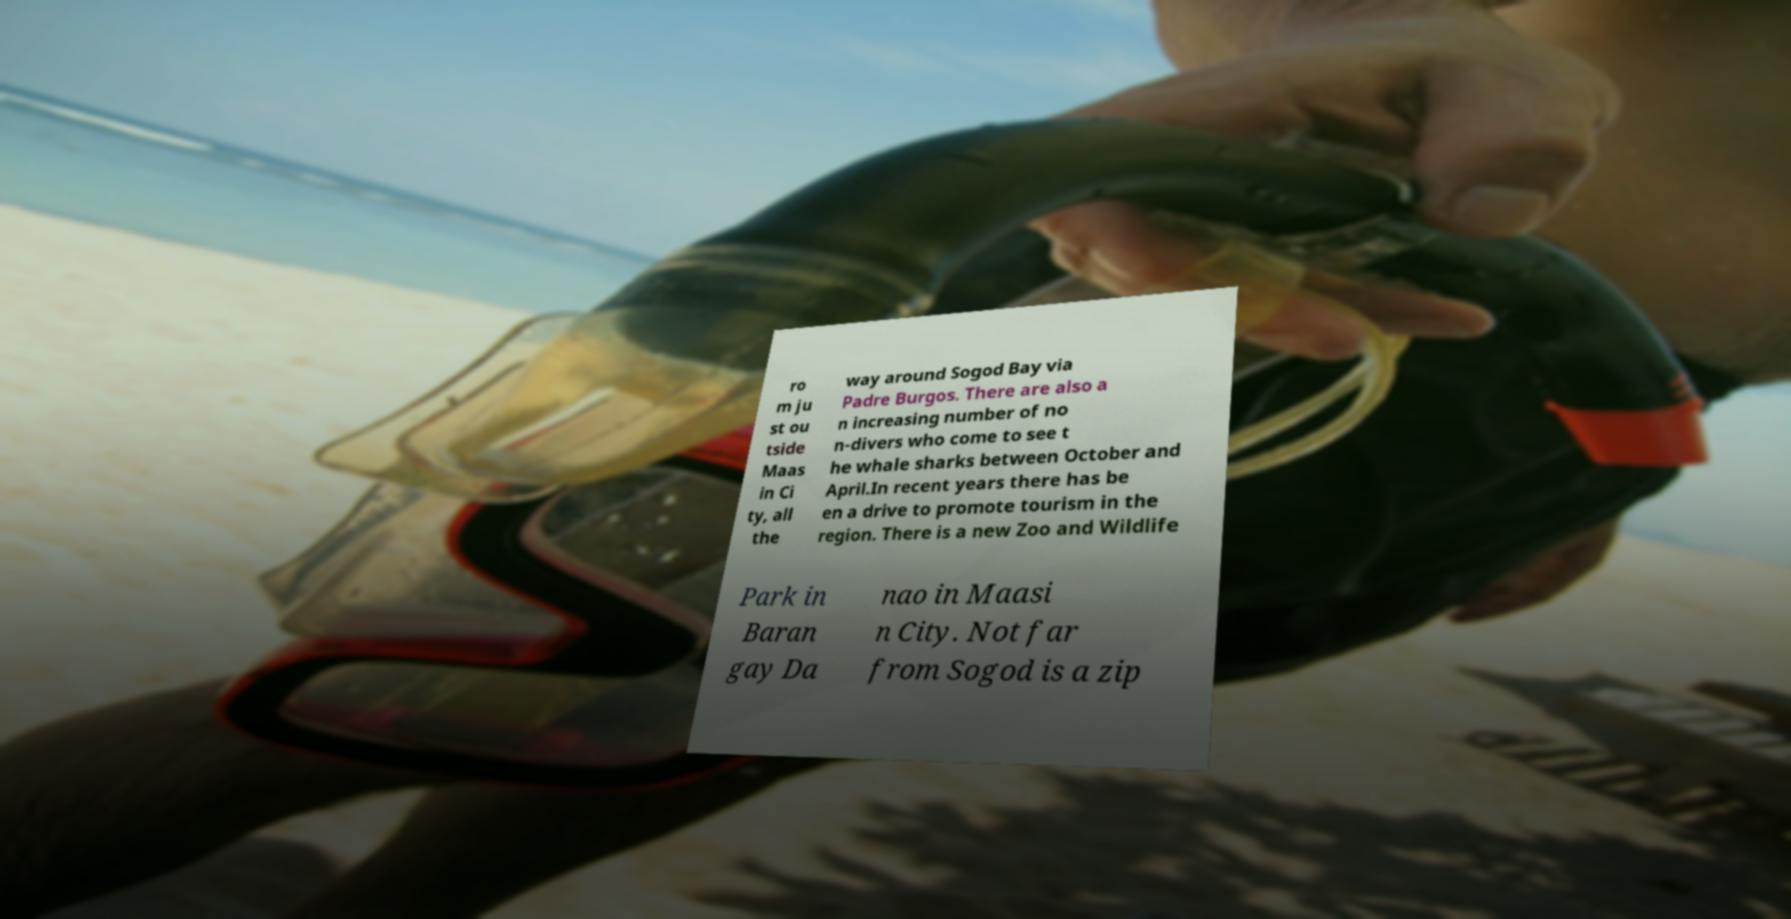For documentation purposes, I need the text within this image transcribed. Could you provide that? ro m ju st ou tside Maas in Ci ty, all the way around Sogod Bay via Padre Burgos. There are also a n increasing number of no n-divers who come to see t he whale sharks between October and April.In recent years there has be en a drive to promote tourism in the region. There is a new Zoo and Wildlife Park in Baran gay Da nao in Maasi n City. Not far from Sogod is a zip 